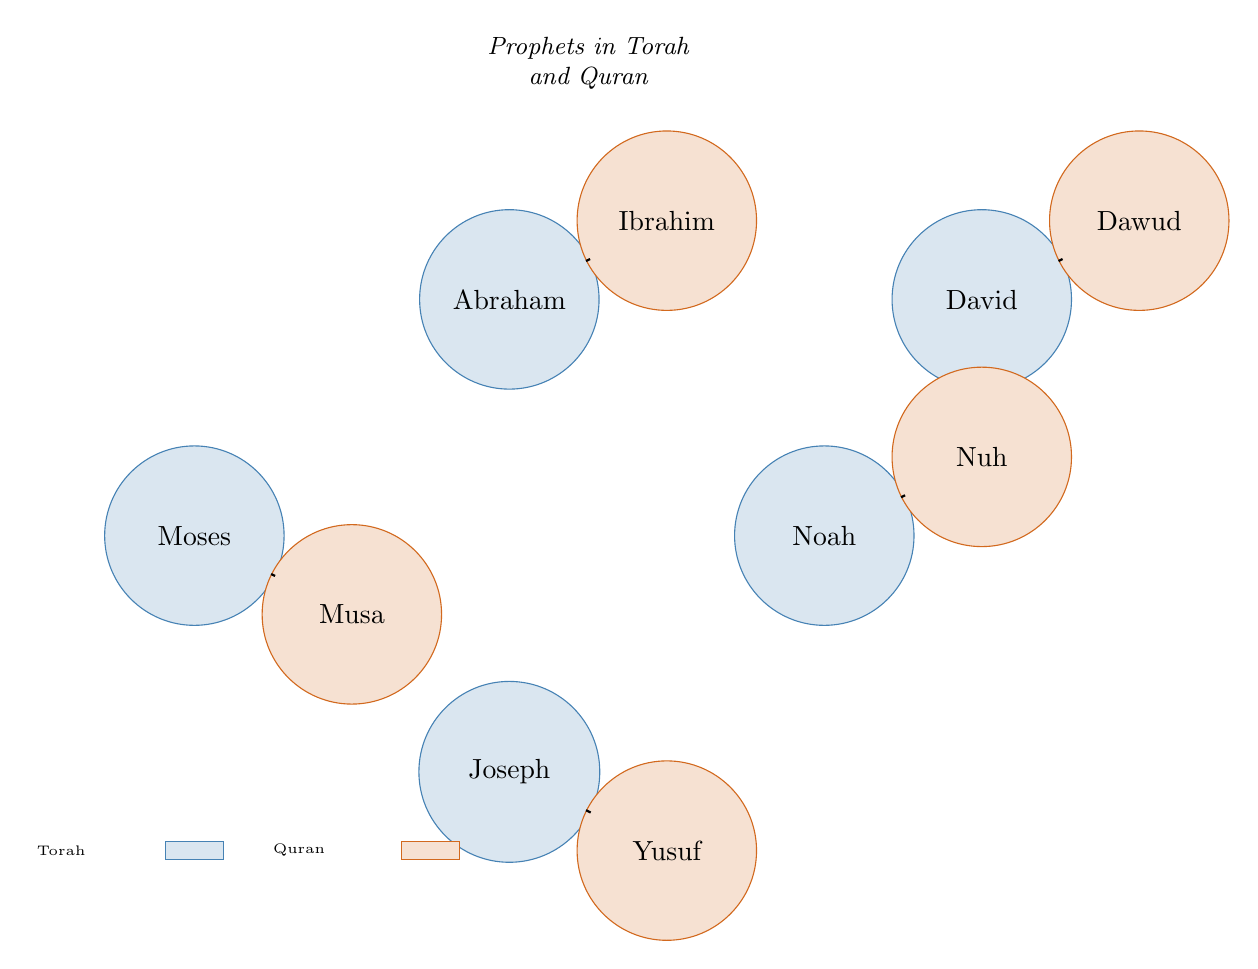What are the two names associated with Moses? The diagram shows a connection between the nodes "Moses" and "Musa" indicating they refer to the same prophet in the Torah and the Quran.
Answer: Moses, Musa How many prophets are depicted in the diagram? The diagram includes five nodes representing prophets from the Torah and five corresponding nodes from the Quran. Counting the unique nodes reveals a total of five prophets.
Answer: 5 Which prophet in the Torah corresponds to Dawud in the Quran? The diagram presents a direct link between "David" in the Torah and "Dawud" in the Quran, indicating they are the same person.
Answer: David What is the relationship between Noah and Nuh in the diagram? The diagram connects the nodes "Noah" and "Nuh" with a visual link. This indicates that they refer to the same prophet named Noah in the Torah and Nuh in the Quran.
Answer: Same prophet How many connections (links) are there in total? The diagram displays five links between the nodes, one for each pair of corresponding prophets. Counting these links gives a total of five.
Answer: 5 Which two prophets in the diagram are associated with the name Yusuf? The diagram shows that "Joseph" is linked to "Yusuf," which indicates their connection as counterparts in the respective texts.
Answer: Joseph, Yusuf In which collection is Moses mentioned? The node "Moses" is colored and labeled, indicating that he is featured in the Torah, as signified by the color coding in the diagram.
Answer: Torah Which prophet does Ibrahim correspond to? The diagram indicates a link from "Abraham" in the Torah to "Ibrahim" in the Quran, denoting they refer to the same individual.
Answer: Ibrahim Which two prophets are both associated with the name Nuh? The diagram connects "Noah" from the Torah to "Nuh" in the Quran, demonstrating they share the same identity across the two texts.
Answer: Noah, Nuh 